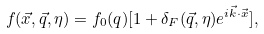Convert formula to latex. <formula><loc_0><loc_0><loc_500><loc_500>f ( \vec { x } , \vec { q } , \eta ) = f _ { 0 } ( q ) [ 1 + \delta _ { F } ( \vec { q } , \eta ) e ^ { i \vec { k } \cdot \vec { x } } ] ,</formula> 